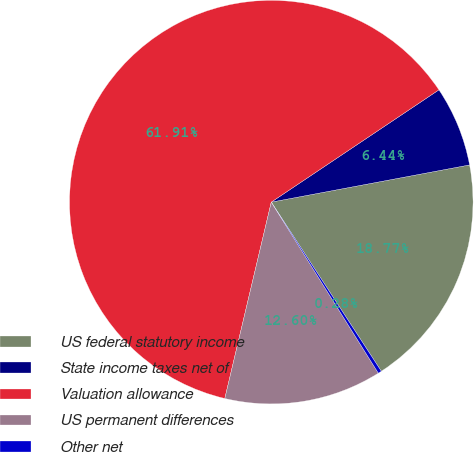Convert chart. <chart><loc_0><loc_0><loc_500><loc_500><pie_chart><fcel>US federal statutory income<fcel>State income taxes net of<fcel>Valuation allowance<fcel>US permanent differences<fcel>Other net<nl><fcel>18.77%<fcel>6.44%<fcel>61.91%<fcel>12.6%<fcel>0.28%<nl></chart> 